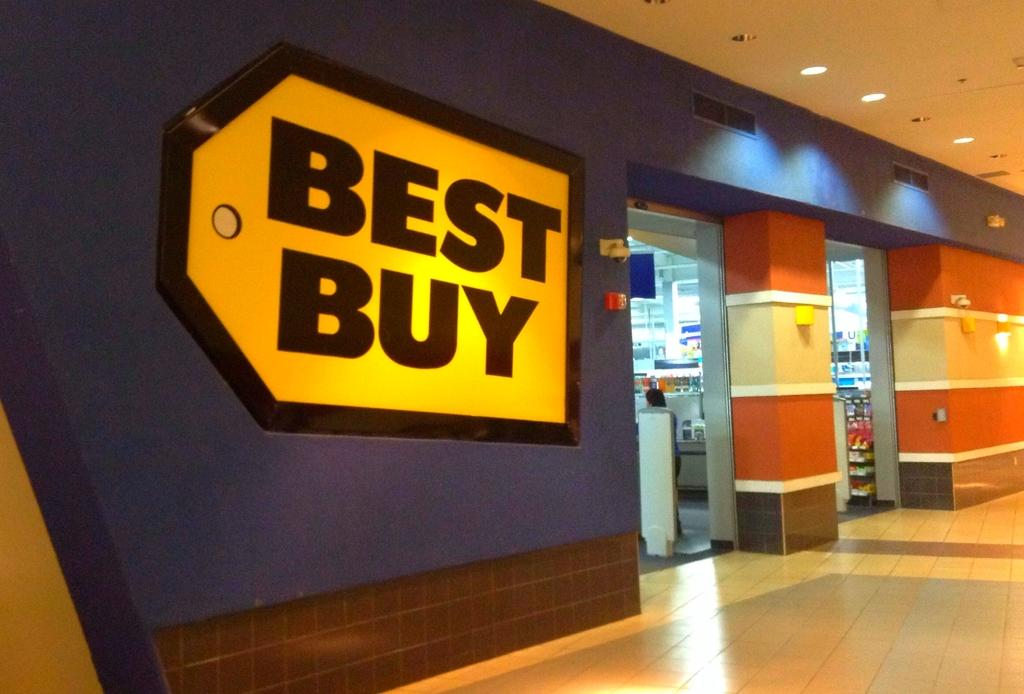<image>
Describe the image concisely. A large best buy sign is built into the wall of the building. 